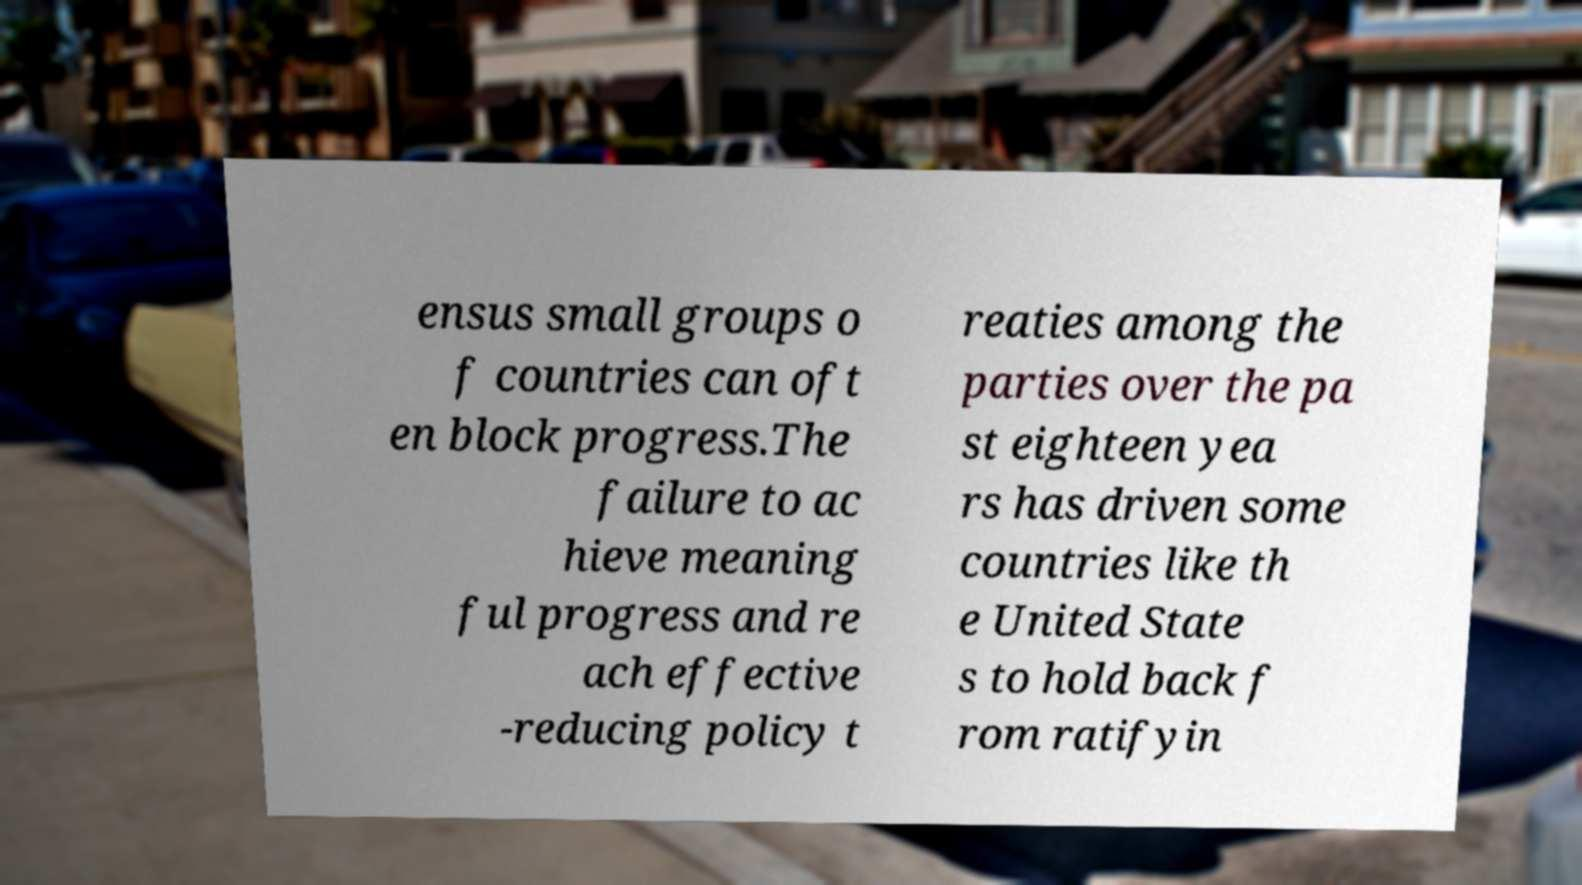Please read and relay the text visible in this image. What does it say? ensus small groups o f countries can oft en block progress.The failure to ac hieve meaning ful progress and re ach effective -reducing policy t reaties among the parties over the pa st eighteen yea rs has driven some countries like th e United State s to hold back f rom ratifyin 